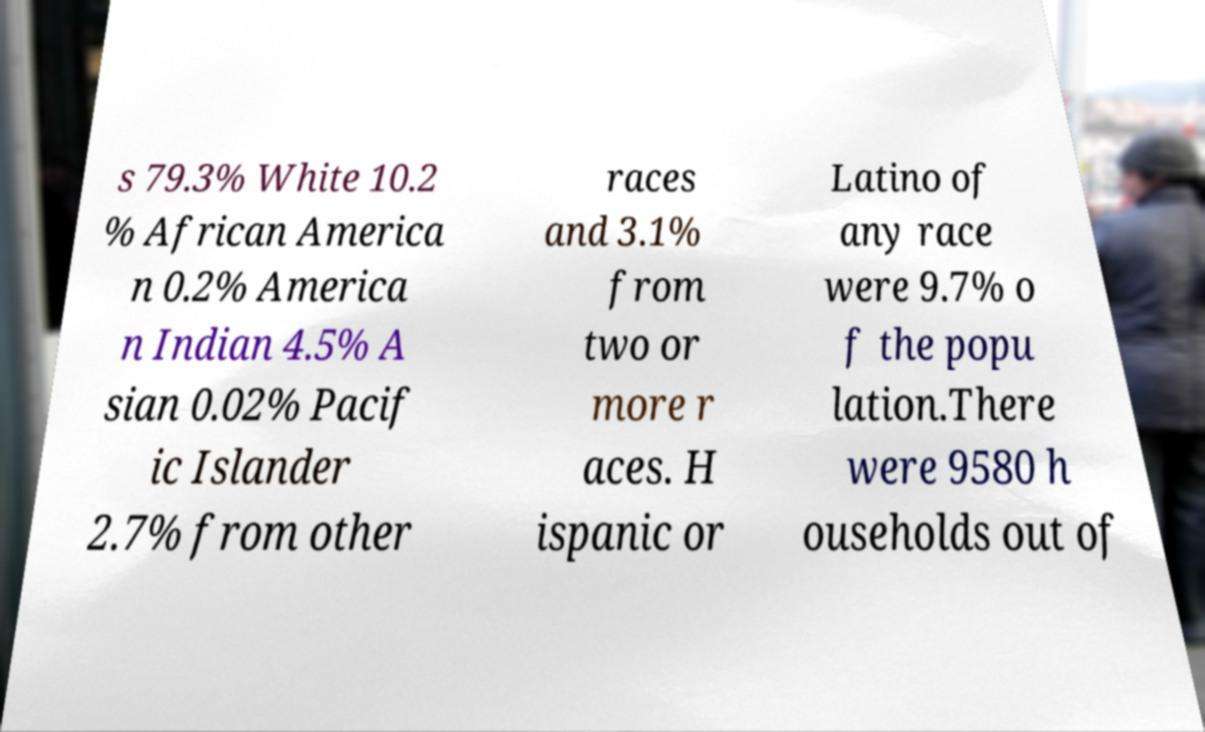Please identify and transcribe the text found in this image. s 79.3% White 10.2 % African America n 0.2% America n Indian 4.5% A sian 0.02% Pacif ic Islander 2.7% from other races and 3.1% from two or more r aces. H ispanic or Latino of any race were 9.7% o f the popu lation.There were 9580 h ouseholds out of 